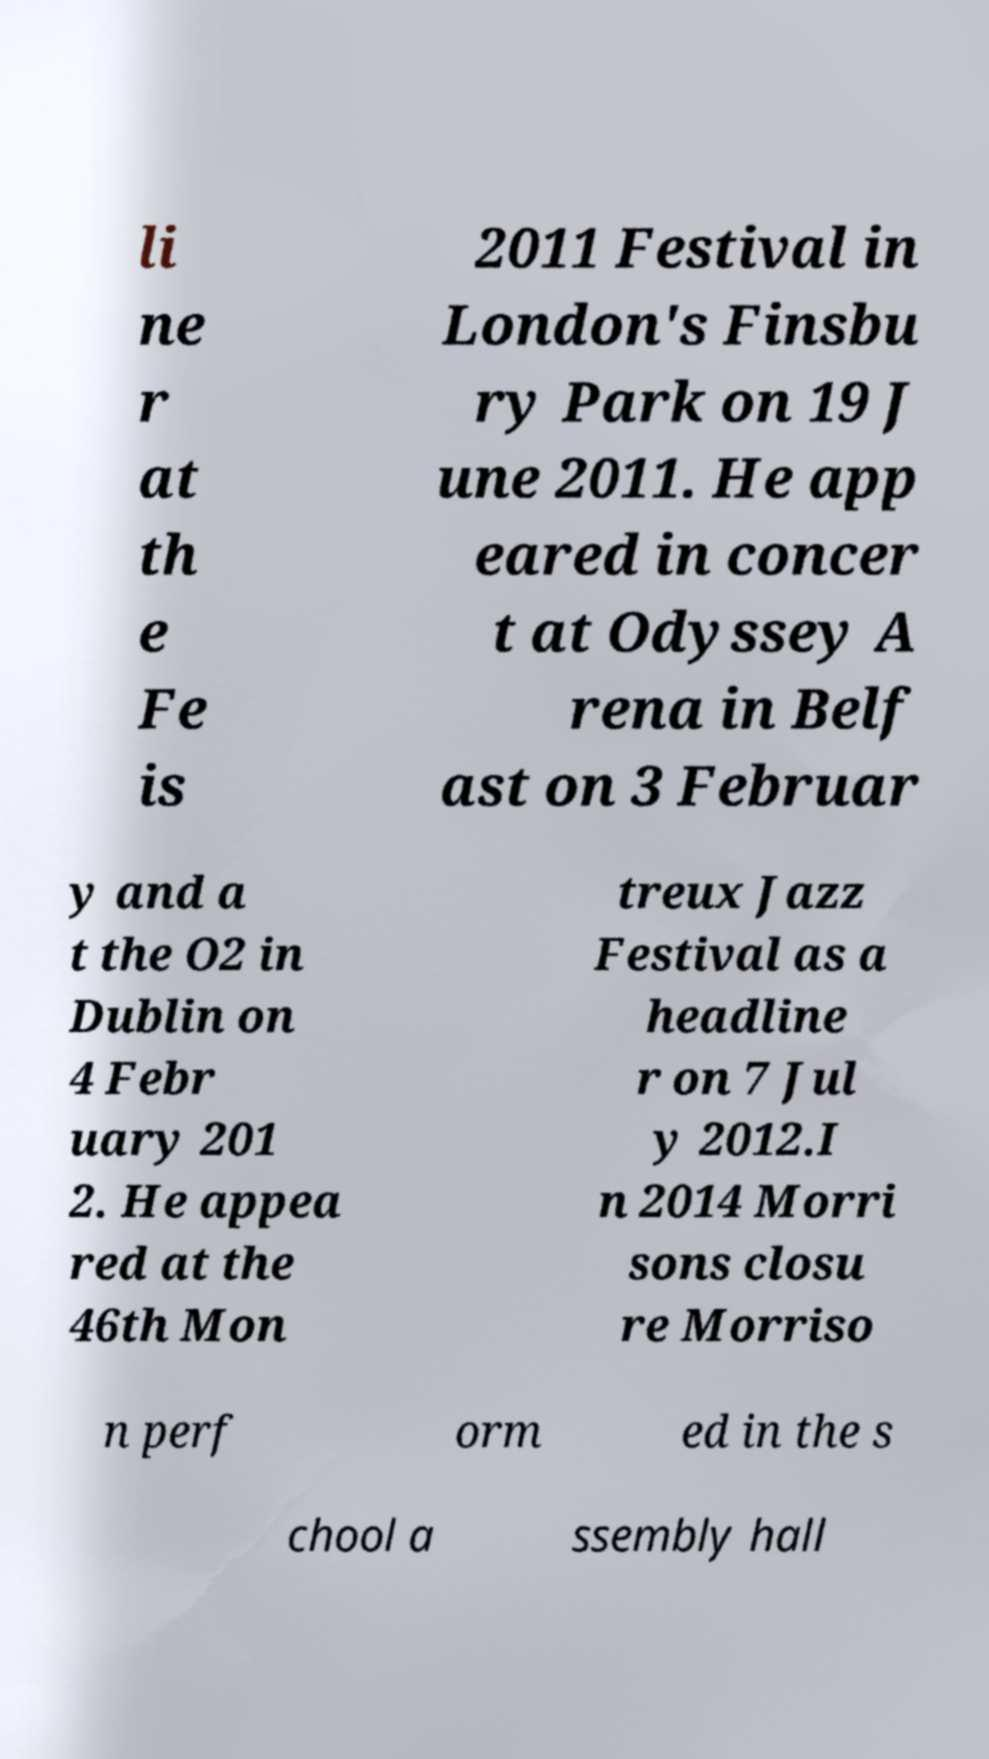Can you read and provide the text displayed in the image?This photo seems to have some interesting text. Can you extract and type it out for me? li ne r at th e Fe is 2011 Festival in London's Finsbu ry Park on 19 J une 2011. He app eared in concer t at Odyssey A rena in Belf ast on 3 Februar y and a t the O2 in Dublin on 4 Febr uary 201 2. He appea red at the 46th Mon treux Jazz Festival as a headline r on 7 Jul y 2012.I n 2014 Morri sons closu re Morriso n perf orm ed in the s chool a ssembly hall 